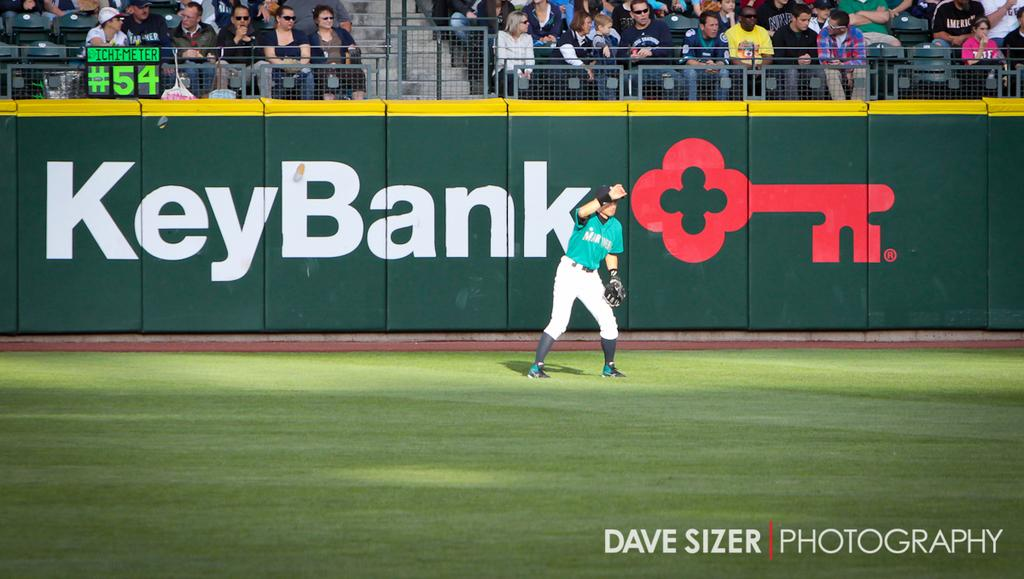<image>
Offer a succinct explanation of the picture presented. An outfielder is standing during a game with an ad for Key Bank behind him. 